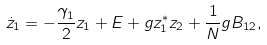Convert formula to latex. <formula><loc_0><loc_0><loc_500><loc_500>\dot { z } _ { 1 } = - \frac { \gamma _ { 1 } } { 2 } z _ { 1 } + E + g z ^ { * } _ { 1 } z _ { 2 } + \frac { 1 } { N } g B _ { 1 2 } ,</formula> 